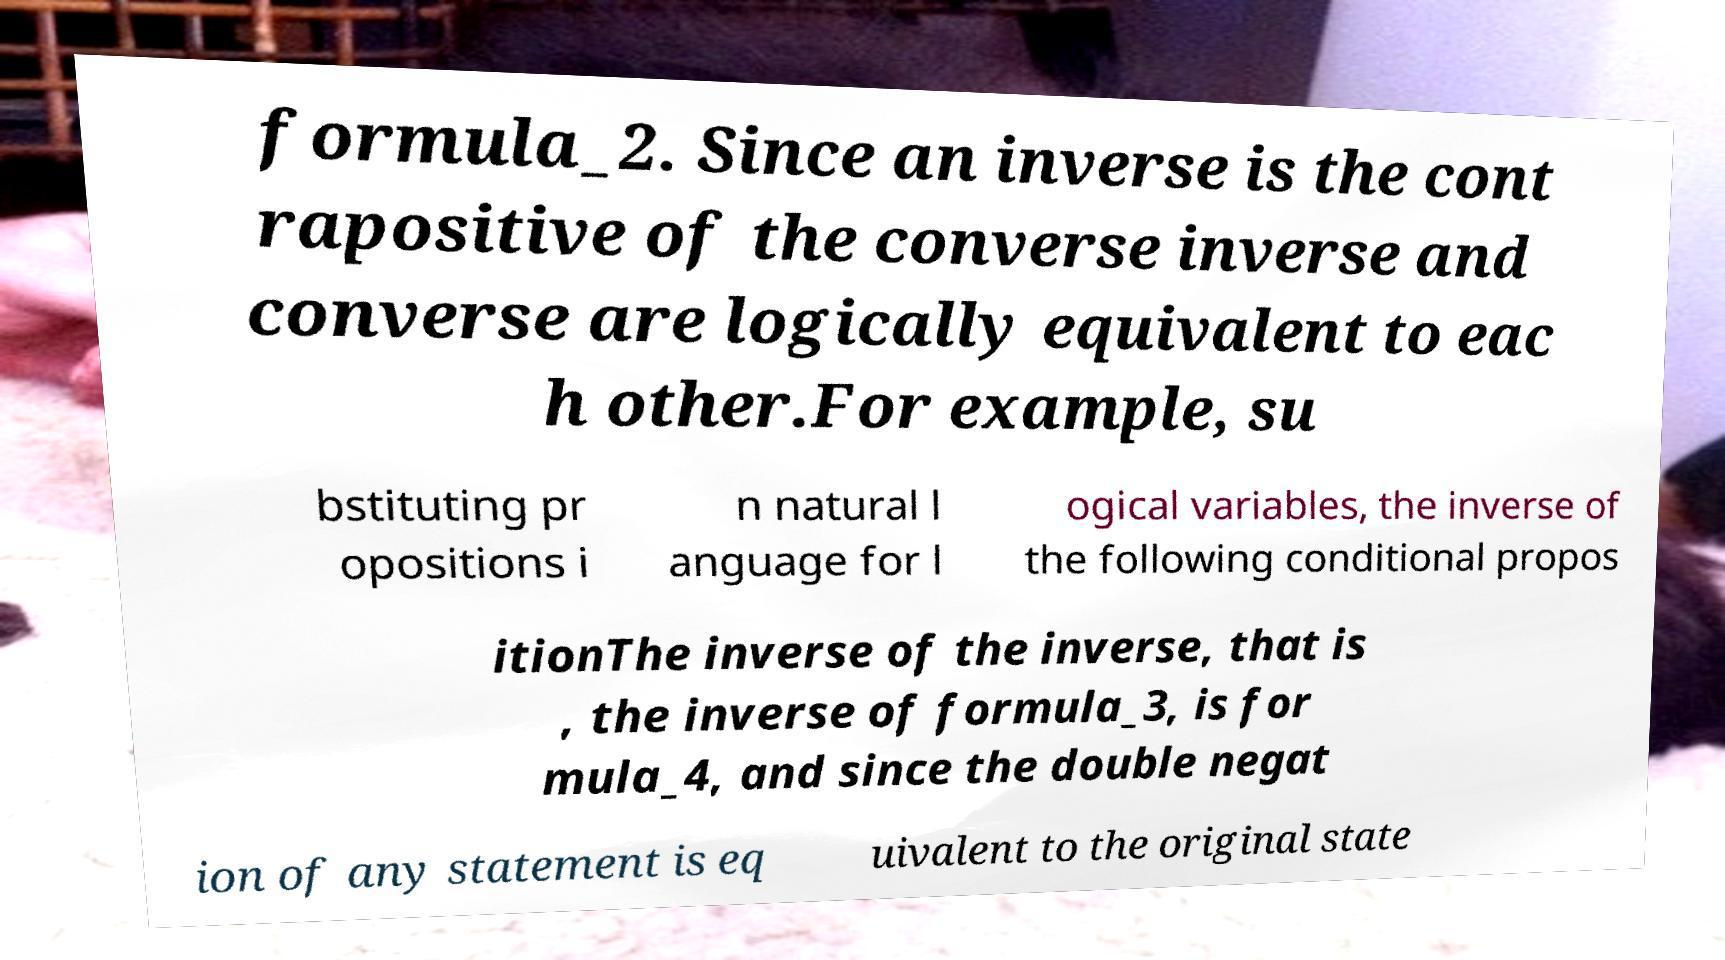Can you accurately transcribe the text from the provided image for me? formula_2. Since an inverse is the cont rapositive of the converse inverse and converse are logically equivalent to eac h other.For example, su bstituting pr opositions i n natural l anguage for l ogical variables, the inverse of the following conditional propos itionThe inverse of the inverse, that is , the inverse of formula_3, is for mula_4, and since the double negat ion of any statement is eq uivalent to the original state 